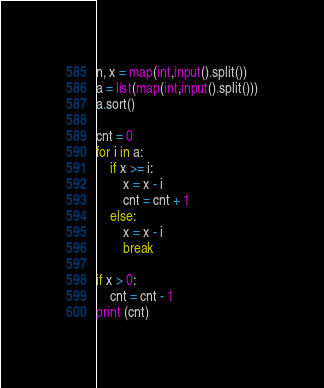Convert code to text. <code><loc_0><loc_0><loc_500><loc_500><_Python_>n, x = map(int,input().split())
a = list(map(int,input().split()))
a.sort()

cnt = 0
for i in a:
    if x >= i:
        x = x - i
        cnt = cnt + 1
    else:
        x = x - i
        break

if x > 0:
    cnt = cnt - 1
print (cnt)
</code> 